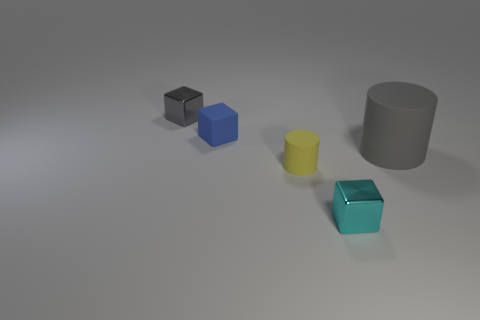Are there any tiny brown cylinders that have the same material as the gray cube?
Offer a very short reply. No. Are there any tiny gray metallic cubes that are to the right of the metal thing that is behind the small shiny cube in front of the small gray metallic object?
Make the answer very short. No. What number of other things are there of the same shape as the small gray object?
Provide a short and direct response. 2. What color is the thing that is right of the tiny metal object on the right side of the tiny block behind the blue cube?
Provide a short and direct response. Gray. What number of tiny cyan metallic objects are there?
Keep it short and to the point. 1. What number of tiny objects are either rubber cubes or yellow matte objects?
Give a very brief answer. 2. What is the shape of the cyan thing that is the same size as the rubber cube?
Your answer should be compact. Cube. Is there anything else that is the same size as the yellow rubber cylinder?
Your answer should be very brief. Yes. There is a gray object that is behind the matte cylinder to the right of the tiny cyan shiny thing; what is it made of?
Make the answer very short. Metal. Do the cyan shiny cube and the gray cylinder have the same size?
Ensure brevity in your answer.  No. 